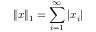<formula> <loc_0><loc_0><loc_500><loc_500>\| x \| _ { 1 } = \sum _ { i = 1 } ^ { \infty } | x _ { i } |</formula> 